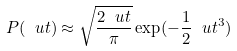<formula> <loc_0><loc_0><loc_500><loc_500>P ( \ u t ) \approx \sqrt { \frac { 2 \ u t } { \pi } } \exp ( - \frac { 1 } { 2 } \ u t ^ { 3 } )</formula> 